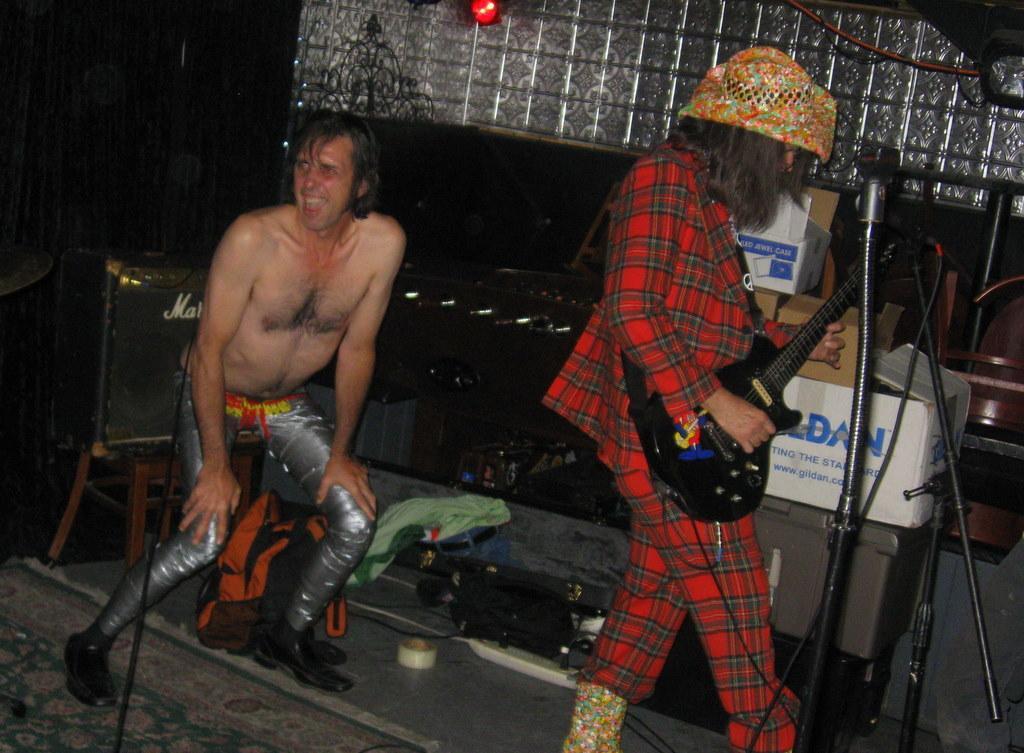Please provide a concise description of this image. There is a man who is wearing a checked suit and a floral cap. He is playing a guitar. In front of him there is a microphone which is attached to a stand. p Beside him there are cartons and a plastic box. Behind the person there is another man, who is in a squat position. He is not wearing a shirt. A bag is there behind him ,clothes are beside him. On the floor there is a carpet. Behind that person there is a speaker on a table. There is a curtain and there is glass wall with a red light. There is a table football board. 